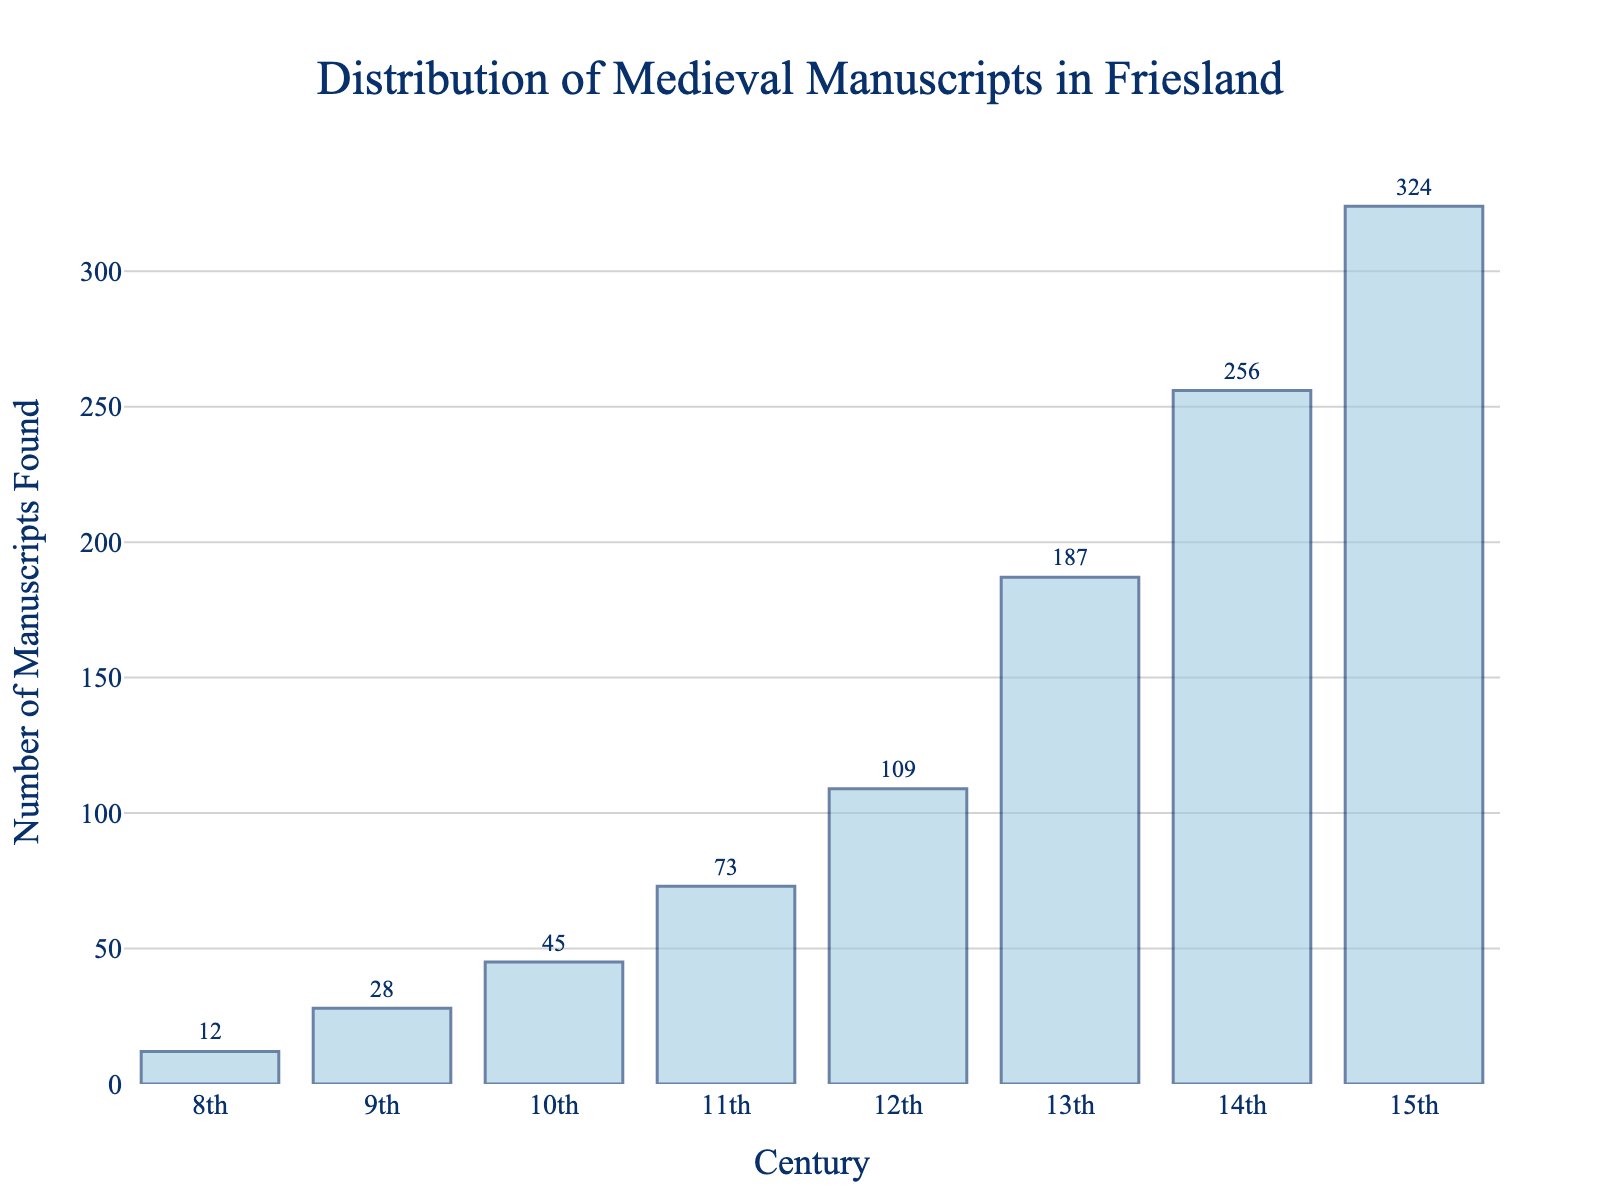Which century had the highest number of manuscripts found? By looking at the heights of the bars, the bar representing the 15th century is the tallest, indicating the highest number of manuscripts found.
Answer: 15th century Which century had the fewest manuscripts found? The shortest bar in the chart represents the 8th century, indicating the fewest manuscripts found.
Answer: 8th century What is the difference in the number of manuscripts found between the 12th and 13th centuries? Subtract the number of manuscripts found in the 12th century (109) from the number found in the 13th century (187). So, 187 - 109 = 78.
Answer: 78 Which centuries had a total of over 100 manuscripts found? Summing the manuscripts from each century and reviewing the data, the 12th century (109), 13th century (187), 14th century (256), and 15th century (324) each exceed 100 manuscripts.
Answer: 12th, 13th, 14th, 15th centuries How does the number of manuscripts found in the 10th century compare with the 9th century? Comparing the heights of the bars, the 10th century (45) had more manuscripts found than the 9th century (28).
Answer: 10th century had more What is the average number of manuscripts found from the 8th to the 15th centuries? Sum the manuscripts found (12+28+45+73+109+187+256+324 = 1034) and divide by the number of centuries (8). So, 1034 / 8 = 129.25.
Answer: 129.25 Between which two consecutive centuries was the increase in manuscripts found the greatest? Compare the differences between consecutive bars: (28-12=16), (45-28=17), (73-45=28), (109-73=36), (187-109=78), (256-187=69), (324-256=68). The greatest increase is between the 12th and 13th centuries (78 manuscripts).
Answer: 12th and 13th centuries How many more manuscripts were found in the 14th century compared to the 11th century? Subtract the number found in the 11th century (73) from the number found in the 14th century (256). So, 256 - 73 = 183.
Answer: 183 What percentage of the total manuscripts found were from the 15th century? Calculate the total manuscripts found (1034), and then the portion from the 15th century (324). Compute the percentage: (324/1034) * 100 ≈ 31.34%.
Answer: 31.34% What trend can be observed in the distribution of manuscripts found over the centuries? Observing the heights of the bars, there is a general increasing trend in the number of manuscripts found from the 8th to the 15th centuries.
Answer: Increasing trend 